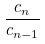<formula> <loc_0><loc_0><loc_500><loc_500>\frac { c _ { n } } { c _ { n - 1 } }</formula> 